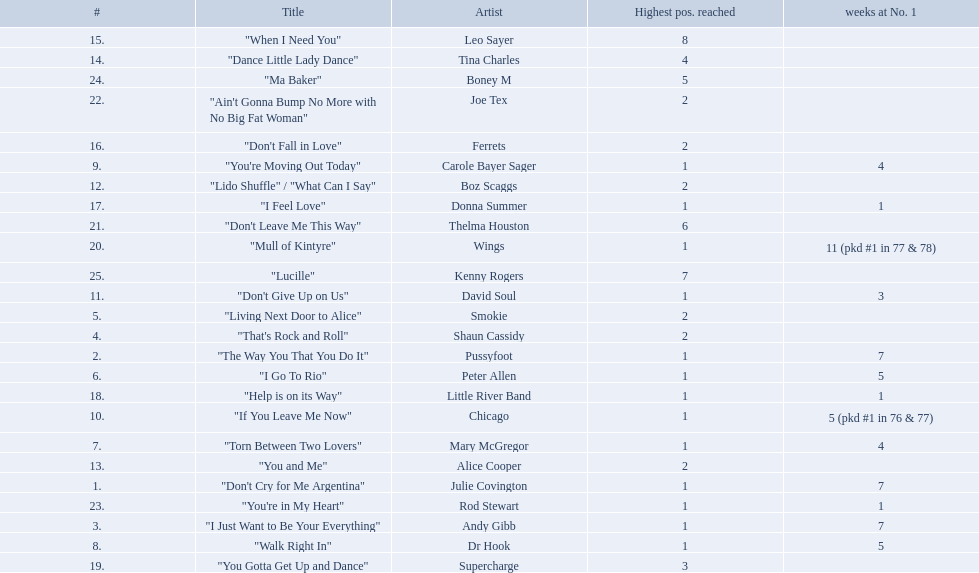How long is the longest amount of time spent at number 1? 11 (pkd #1 in 77 & 78). What song spent 11 weeks at number 1? "Mull of Kintyre". What band had a number 1 hit with this song? Wings. 